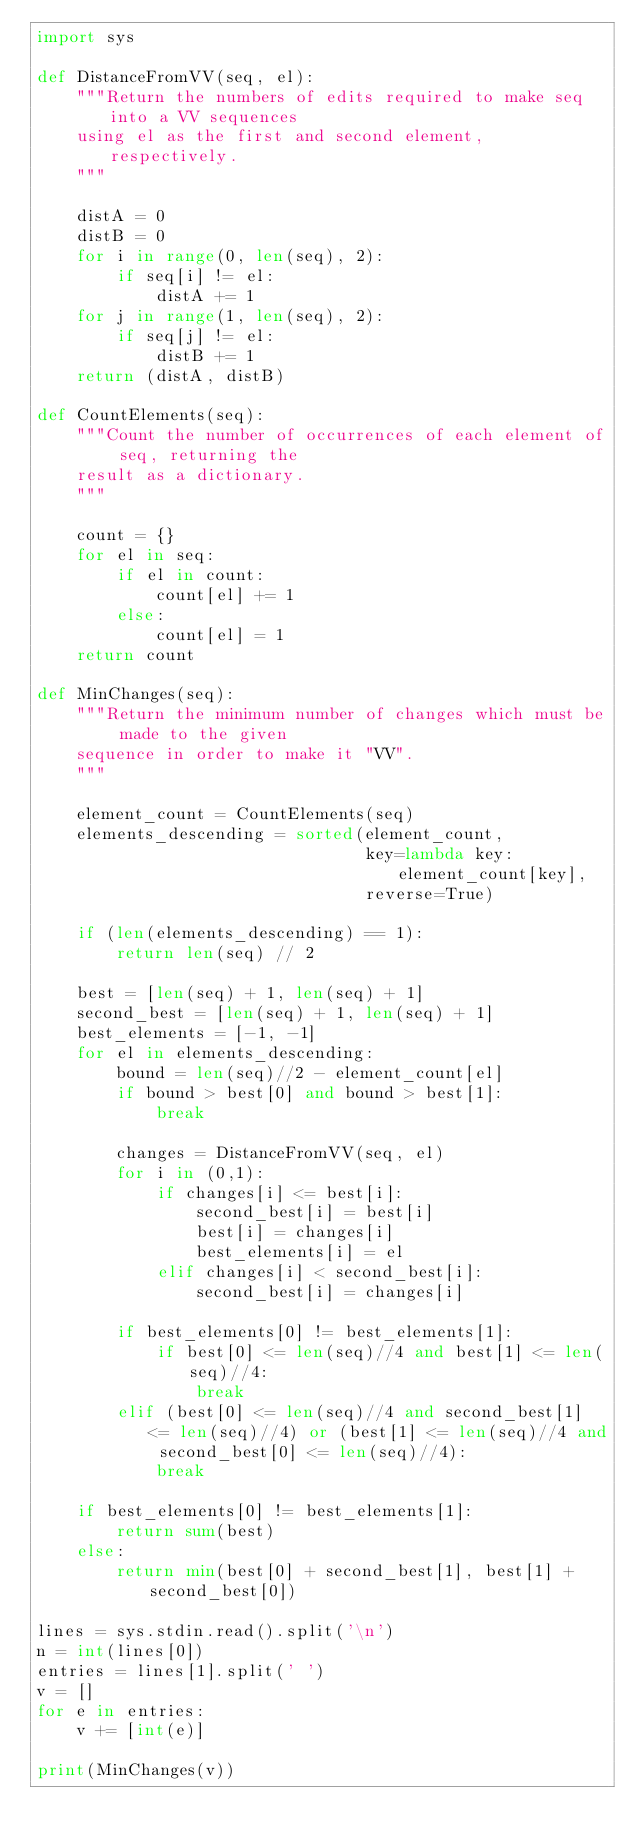Convert code to text. <code><loc_0><loc_0><loc_500><loc_500><_Python_>import sys

def DistanceFromVV(seq, el):
    """Return the numbers of edits required to make seq into a VV sequences
    using el as the first and second element, respectively.
    """

    distA = 0
    distB = 0
    for i in range(0, len(seq), 2):
        if seq[i] != el:
            distA += 1
    for j in range(1, len(seq), 2):
        if seq[j] != el:
            distB += 1
    return (distA, distB)

def CountElements(seq):
    """Count the number of occurrences of each element of seq, returning the 
    result as a dictionary.
    """

    count = {}
    for el in seq:
        if el in count:
            count[el] += 1
        else:
            count[el] = 1
    return count

def MinChanges(seq):
    """Return the minimum number of changes which must be made to the given 
    sequence in order to make it "VV".
    """

    element_count = CountElements(seq)
    elements_descending = sorted(element_count, 
                                 key=lambda key: element_count[key], 
                                 reverse=True)

    if (len(elements_descending) == 1):
        return len(seq) // 2

    best = [len(seq) + 1, len(seq) + 1]
    second_best = [len(seq) + 1, len(seq) + 1]
    best_elements = [-1, -1]
    for el in elements_descending:
        bound = len(seq)//2 - element_count[el]
        if bound > best[0] and bound > best[1]:
            break

        changes = DistanceFromVV(seq, el)
        for i in (0,1):
            if changes[i] <= best[i]:
                second_best[i] = best[i]
                best[i] = changes[i]
                best_elements[i] = el
            elif changes[i] < second_best[i]:
                second_best[i] = changes[i]

        if best_elements[0] != best_elements[1]:
            if best[0] <= len(seq)//4 and best[1] <= len(seq)//4:
                break
        elif (best[0] <= len(seq)//4 and second_best[1] <= len(seq)//4) or (best[1] <= len(seq)//4 and second_best[0] <= len(seq)//4):
            break

    if best_elements[0] != best_elements[1]:
        return sum(best)
    else:
        return min(best[0] + second_best[1], best[1] + second_best[0])

lines = sys.stdin.read().split('\n')
n = int(lines[0])
entries = lines[1].split(' ')
v = []
for e in entries:
    v += [int(e)]

print(MinChanges(v))
</code> 